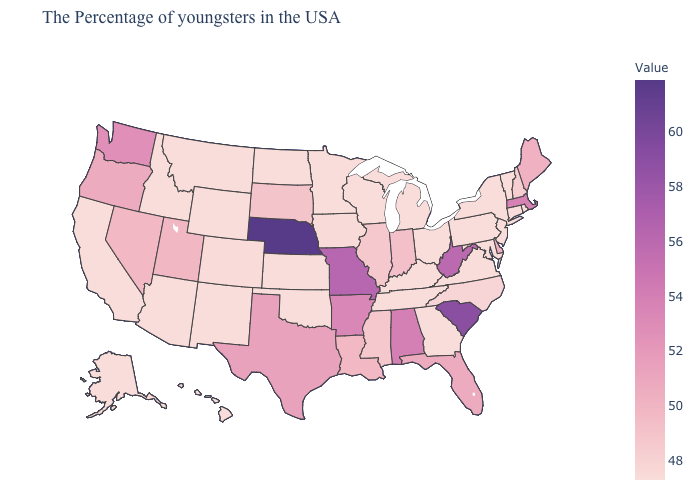Does the map have missing data?
Keep it brief. No. Is the legend a continuous bar?
Answer briefly. Yes. Among the states that border Arizona , which have the highest value?
Short answer required. Utah. Among the states that border Texas , does Louisiana have the highest value?
Write a very short answer. No. 